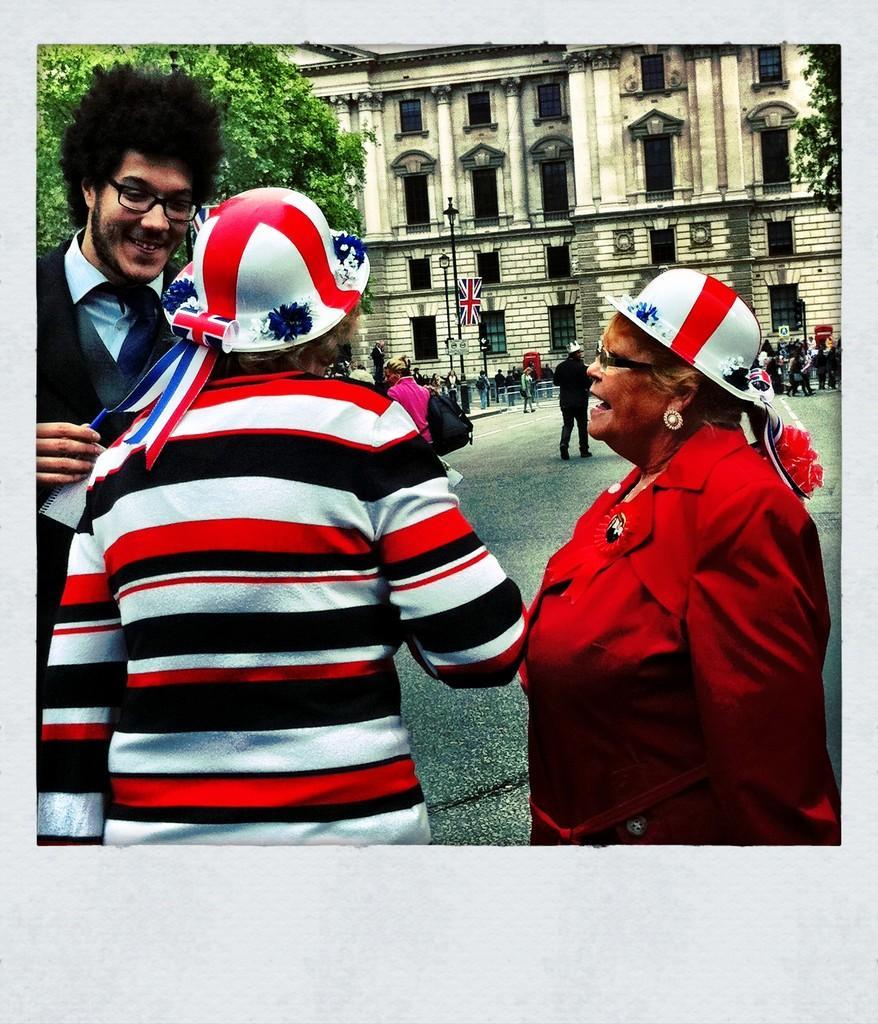Could you give a brief overview of what you see in this image? In this image we can see three persons standing on the road. In the background there is a building, trees, light poles, flag and also few people are visible. 